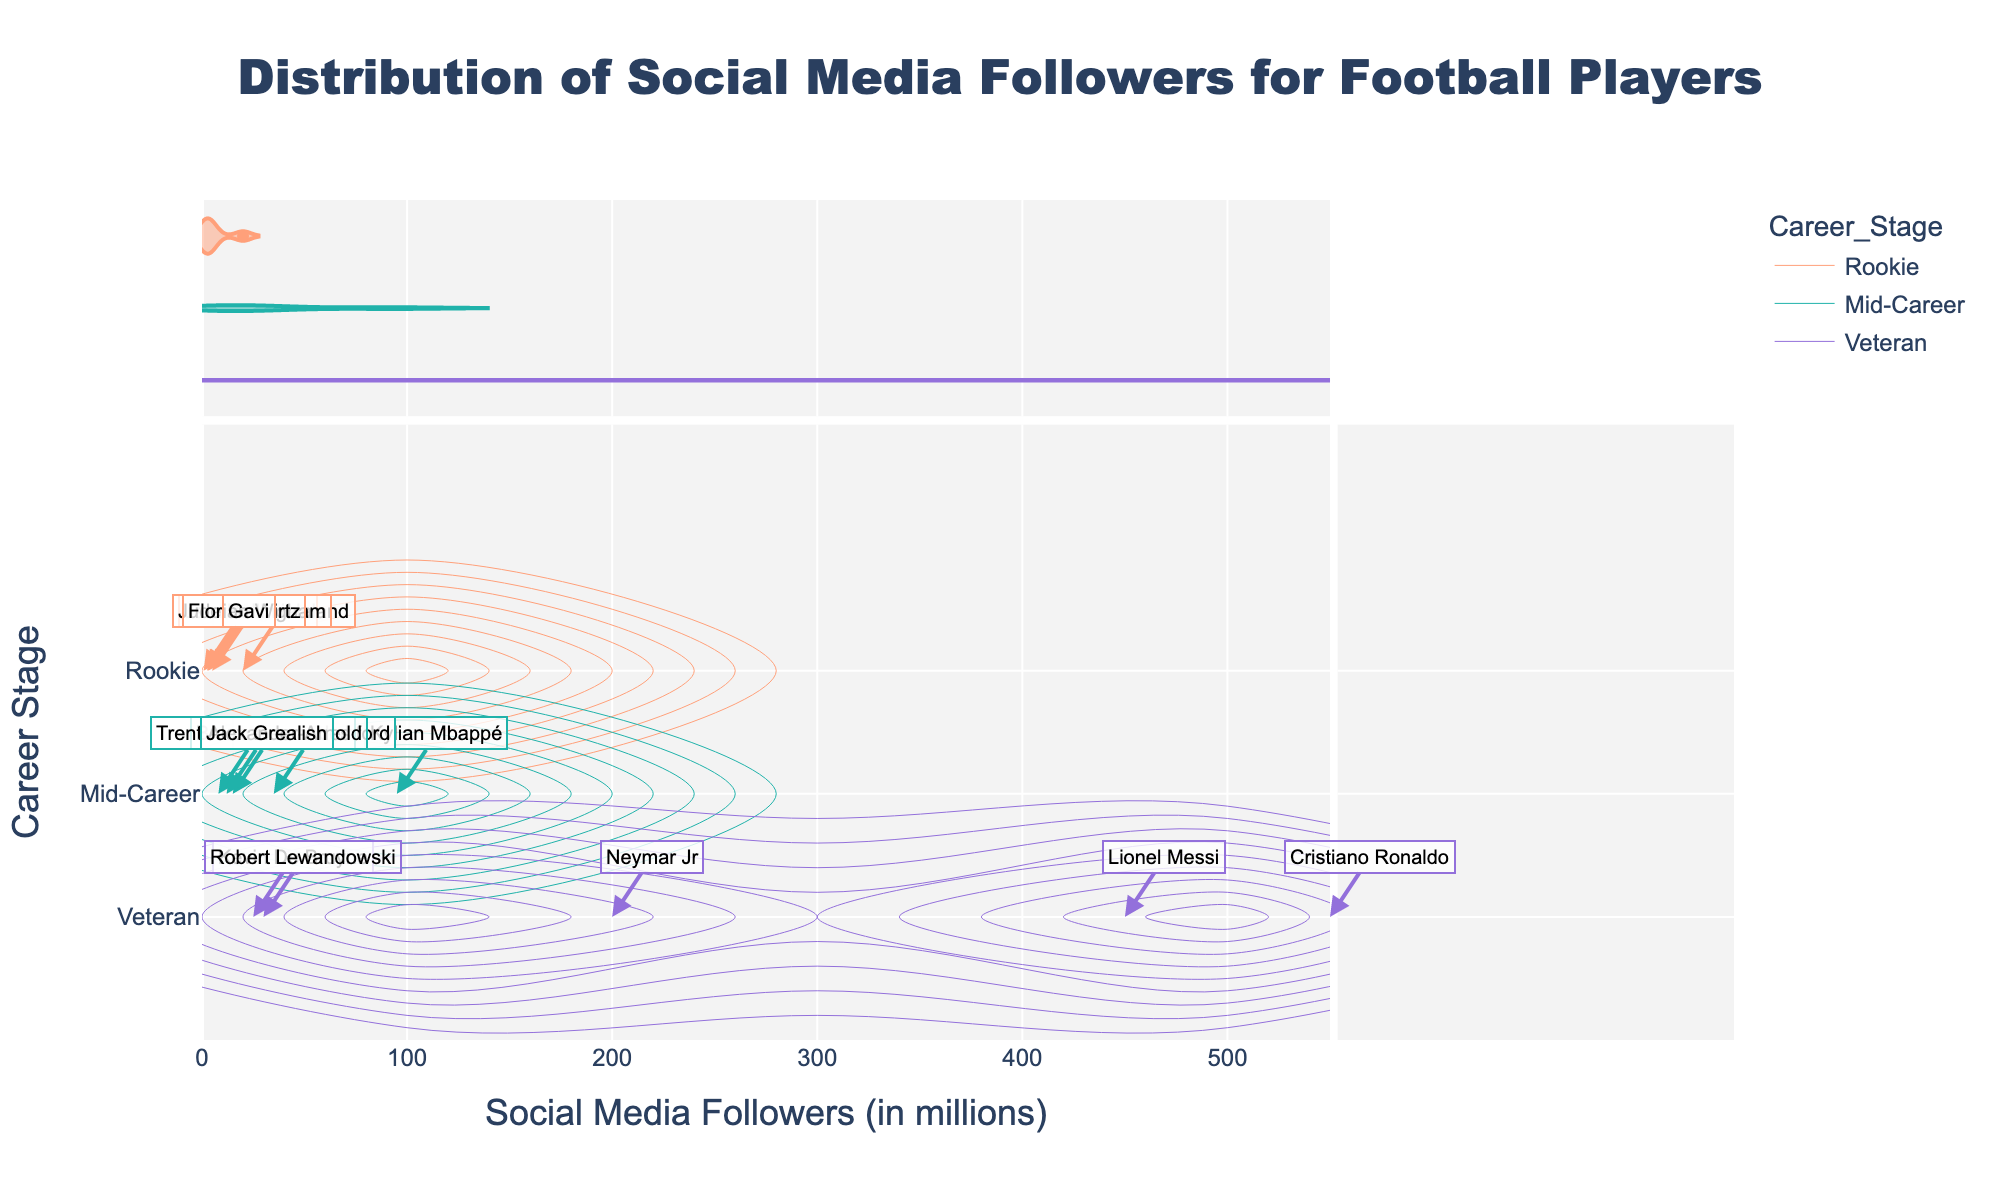What's the title of the figure? The title is usually displayed at the top of the figure, centered and often larger in font size.
Answer: Distribution of Social Media Followers for Football Players What is indicated by the horizontal axis? The horizontal axis typically represents the variable being measured or compared. It is titled 'Social Media Followers (in millions)' indicating it shows the number of social media followers in millions.
Answer: Social Media Followers (in millions) What are the career stages represented in the plot? The different career stages are indicated on the vertical axis and might be highlighted with different colors. The career stages are Rookie, Mid-Career, and Veteran.
Answer: Rookie, Mid-Career, Veteran Which player has the highest number of social media followers? By looking at the x-axis and following it to the rightmost point with an annotation, we see Cristiano Ronaldo with 550 million followers.
Answer: Cristiano Ronaldo Compare the social media followers of Robert Lewandowski and Jack Grealish. Who has more? By locating their annotations on the plot, Robert Lewandowski has 30 million followers, while Jack Grealish has 12 million.
Answer: Robert Lewandowski What's the average number of social media followers for Rookie players? Identify the follower counts for Rookie players (20M, 2.5M, 5M, 800k, 3M). Sum them: 20M + 2.5M + 5M + 800k + 3M = 31.3M. Now, divide by the number of Rookie players, which is 5. So, 31.3M / 5 = 6.26M.
Answer: 6.26 million How does the social media follower distribution differ between Mid-Career and Rookie players? By examining the density contours and annotations, Rookie player followers are mostly below 5M with a few exceptions, while Mid-Career followers are more spread out, with some having significantly higher follower counts like Mbappé at 95M.
Answer: Mid-Career followers are more spread out and generally higher Is there any overlap in the number of followers between Rookie players and Veteran players? The annotations show no Rookie player has followers overlapping into the high range of Veteran players, who start at around 25 million followers.
Answer: No overlap What does the density contour plot indicate about the distribution of followers for Veteran players? The density contours likely show high concentration areas, indicating that a significant number of Veteran players have very high follower counts, mainly above 25 million, with notable peaks around specific players.
Answer: High concentration above 25 million followers Which career stage has the widest range of follower counts? By comparing the spread on the x-axis, Veteran players have the widest range, from Kevin De Bruyne's 25M to Ronaldo's 550M.
Answer: Veteran players 